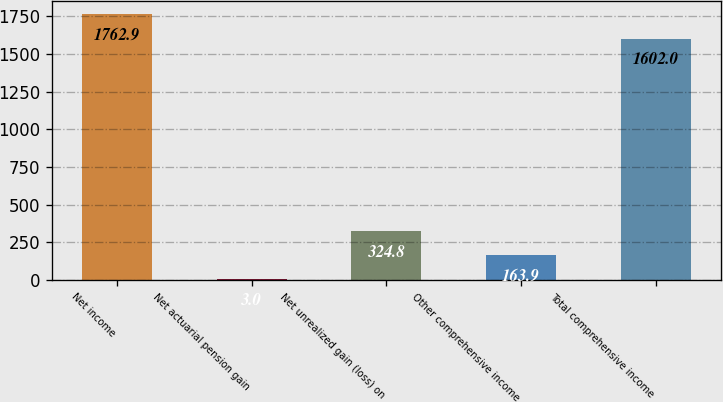Convert chart to OTSL. <chart><loc_0><loc_0><loc_500><loc_500><bar_chart><fcel>Net income<fcel>Net actuarial pension gain<fcel>Net unrealized gain (loss) on<fcel>Other comprehensive income<fcel>Total comprehensive income<nl><fcel>1762.9<fcel>3<fcel>324.8<fcel>163.9<fcel>1602<nl></chart> 